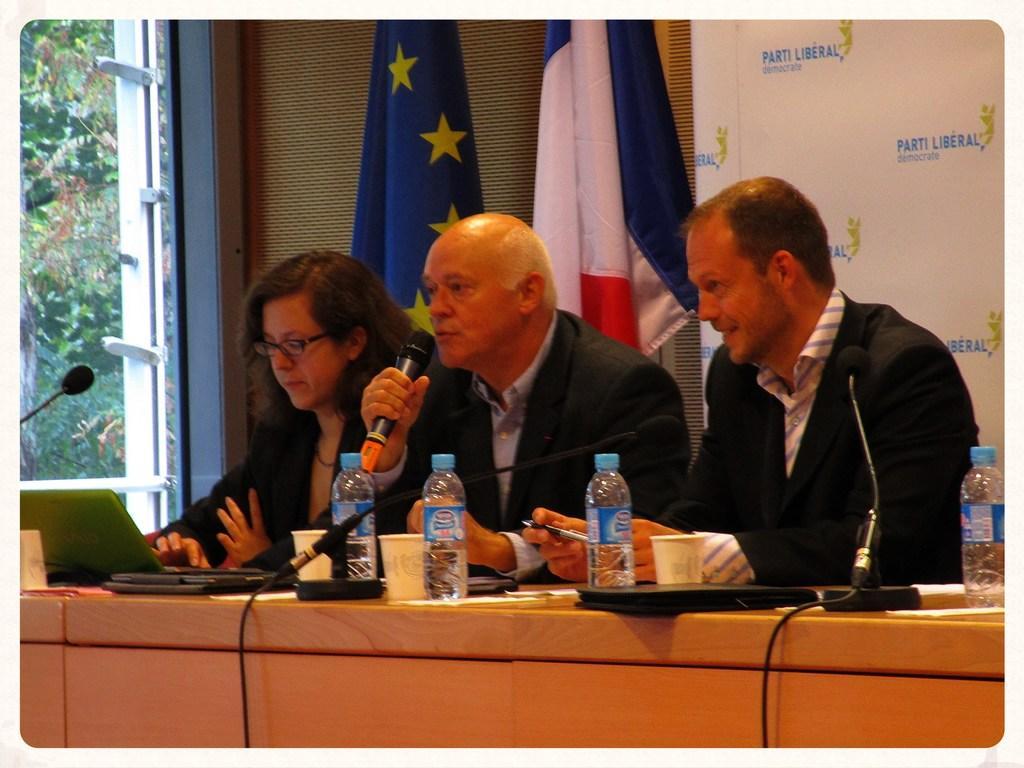Describe this image in one or two sentences. These 3 persons are sitting on a chair. In-front of this person there is a table, on a table there is a mic, laptop, cup, file and bottles. Backside of this person there are flags. Outside of this window we can able to see trees. These three persons wore black suit. This man is holding a mic. 